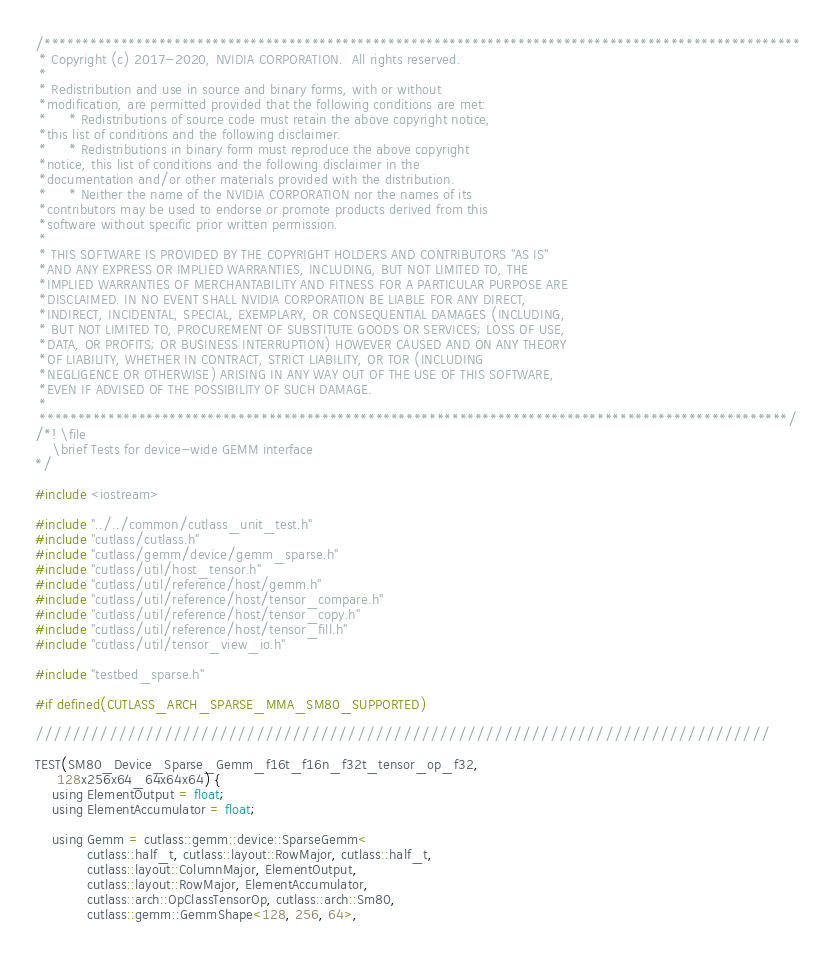<code> <loc_0><loc_0><loc_500><loc_500><_Cuda_>/***************************************************************************************************
 * Copyright (c) 2017-2020, NVIDIA CORPORATION.  All rights reserved.
 *
 * Redistribution and use in source and binary forms, with or without
 *modification, are permitted provided that the following conditions are met:
 *     * Redistributions of source code must retain the above copyright notice,
 *this list of conditions and the following disclaimer.
 *     * Redistributions in binary form must reproduce the above copyright
 *notice, this list of conditions and the following disclaimer in the
 *documentation and/or other materials provided with the distribution.
 *     * Neither the name of the NVIDIA CORPORATION nor the names of its
 *contributors may be used to endorse or promote products derived from this
 *software without specific prior written permission.
 *
 * THIS SOFTWARE IS PROVIDED BY THE COPYRIGHT HOLDERS AND CONTRIBUTORS "AS IS"
 *AND ANY EXPRESS OR IMPLIED WARRANTIES, INCLUDING, BUT NOT LIMITED TO, THE
 *IMPLIED WARRANTIES OF MERCHANTABILITY AND FITNESS FOR A PARTICULAR PURPOSE ARE
 *DISCLAIMED. IN NO EVENT SHALL NVIDIA CORPORATION BE LIABLE FOR ANY DIRECT,
 *INDIRECT, INCIDENTAL, SPECIAL, EXEMPLARY, OR CONSEQUENTIAL DAMAGES (INCLUDING,
 * BUT NOT LIMITED TO, PROCUREMENT OF SUBSTITUTE GOODS OR SERVICES; LOSS OF USE,
 *DATA, OR PROFITS; OR BUSINESS INTERRUPTION) HOWEVER CAUSED AND ON ANY THEORY
 *OF LIABILITY, WHETHER IN CONTRACT, STRICT LIABILITY, OR TOR (INCLUDING
 *NEGLIGENCE OR OTHERWISE) ARISING IN ANY WAY OUT OF THE USE OF THIS SOFTWARE,
 *EVEN IF ADVISED OF THE POSSIBILITY OF SUCH DAMAGE.
 *
 **************************************************************************************************/
/*! \file
    \brief Tests for device-wide GEMM interface
*/

#include <iostream>

#include "../../common/cutlass_unit_test.h"
#include "cutlass/cutlass.h"
#include "cutlass/gemm/device/gemm_sparse.h"
#include "cutlass/util/host_tensor.h"
#include "cutlass/util/reference/host/gemm.h"
#include "cutlass/util/reference/host/tensor_compare.h"
#include "cutlass/util/reference/host/tensor_copy.h"
#include "cutlass/util/reference/host/tensor_fill.h"
#include "cutlass/util/tensor_view_io.h"

#include "testbed_sparse.h"

#if defined(CUTLASS_ARCH_SPARSE_MMA_SM80_SUPPORTED)

////////////////////////////////////////////////////////////////////////////////

TEST(SM80_Device_Sparse_Gemm_f16t_f16n_f32t_tensor_op_f32,
     128x256x64_64x64x64) {
    using ElementOutput = float;
    using ElementAccumulator = float;

    using Gemm = cutlass::gemm::device::SparseGemm<
            cutlass::half_t, cutlass::layout::RowMajor, cutlass::half_t,
            cutlass::layout::ColumnMajor, ElementOutput,
            cutlass::layout::RowMajor, ElementAccumulator,
            cutlass::arch::OpClassTensorOp, cutlass::arch::Sm80,
            cutlass::gemm::GemmShape<128, 256, 64>,</code> 